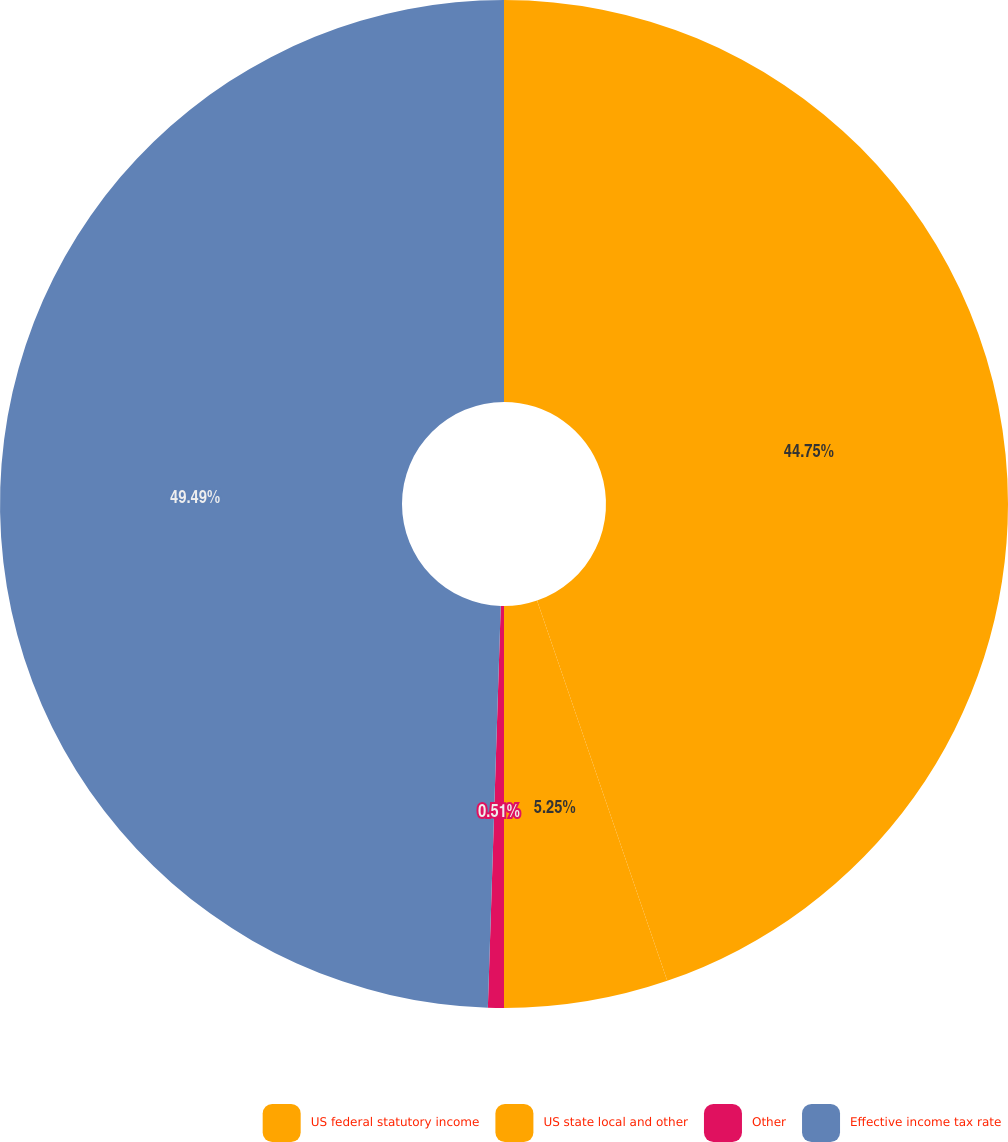Convert chart. <chart><loc_0><loc_0><loc_500><loc_500><pie_chart><fcel>US federal statutory income<fcel>US state local and other<fcel>Other<fcel>Effective income tax rate<nl><fcel>44.75%<fcel>5.25%<fcel>0.51%<fcel>49.49%<nl></chart> 